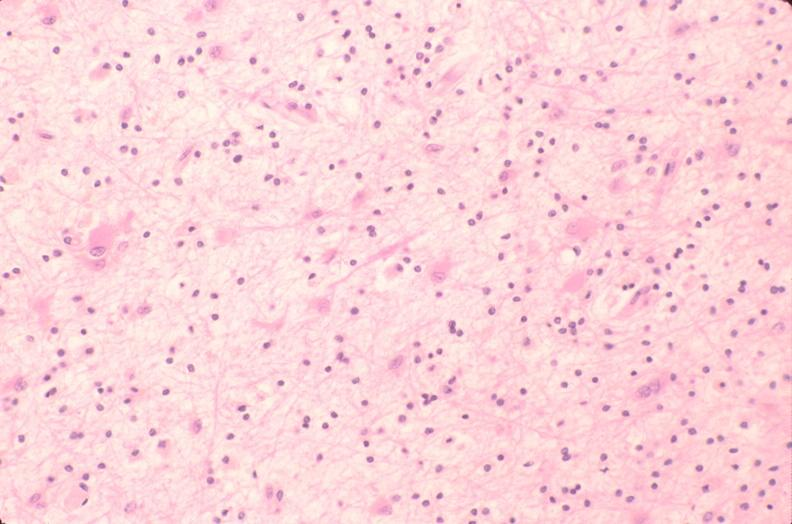does clostridial postmortem growth show brain, encephalomalasia?
Answer the question using a single word or phrase. No 